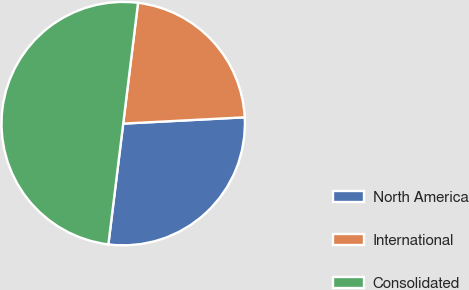Convert chart to OTSL. <chart><loc_0><loc_0><loc_500><loc_500><pie_chart><fcel>North America<fcel>International<fcel>Consolidated<nl><fcel>27.77%<fcel>22.23%<fcel>50.0%<nl></chart> 